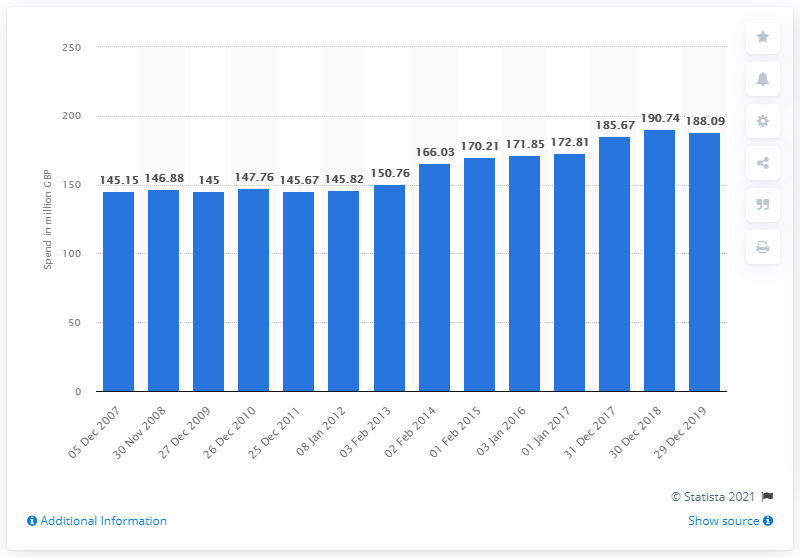Indicate a few pertinent items in this graphic. The amount spent on quiches and flans in the 52 week period ending December 29th, 2019 was 188.09. 